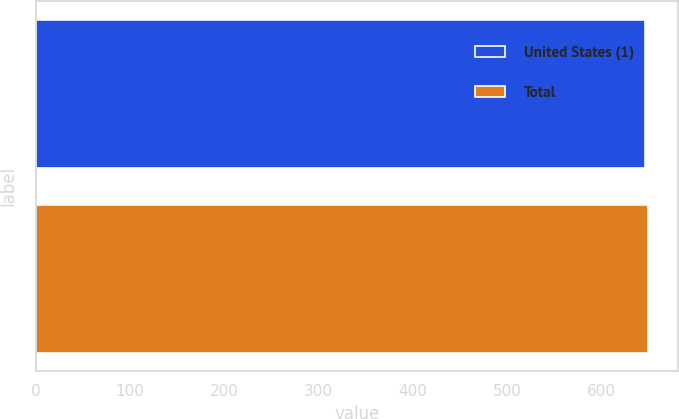<chart> <loc_0><loc_0><loc_500><loc_500><bar_chart><fcel>United States (1)<fcel>Total<nl><fcel>645.2<fcel>648.6<nl></chart> 